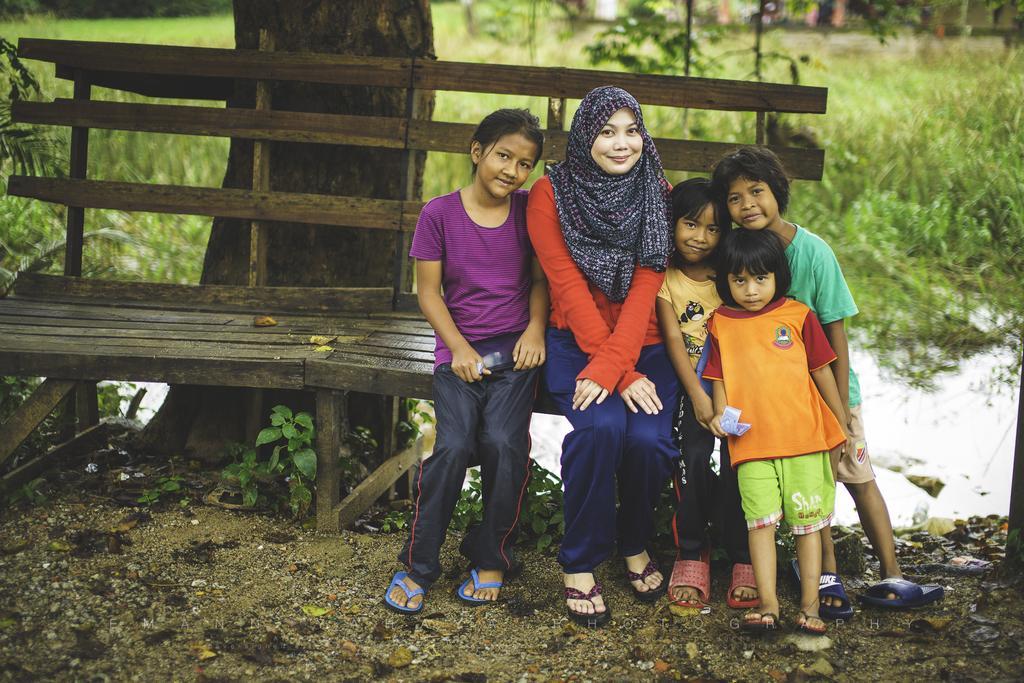How would you summarize this image in a sentence or two? In this image we can see a few people, among them, some are sitting on the bench and some are standing, there are some plants, trees, water and grass. 